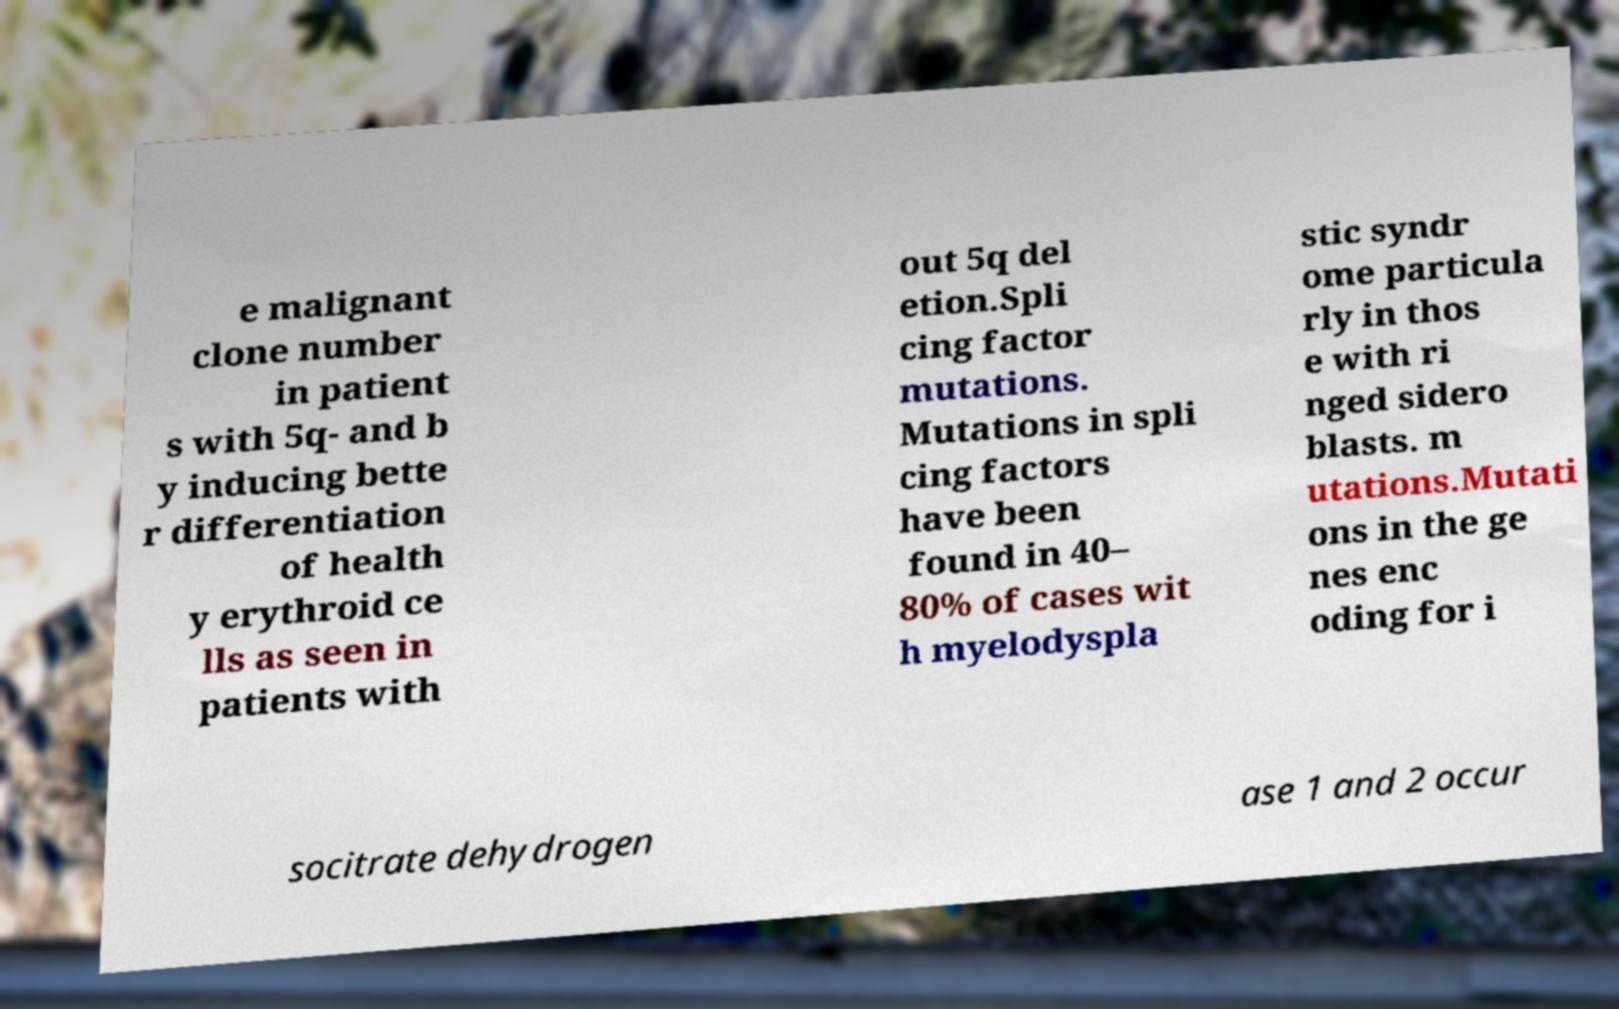Can you accurately transcribe the text from the provided image for me? e malignant clone number in patient s with 5q- and b y inducing bette r differentiation of health y erythroid ce lls as seen in patients with out 5q del etion.Spli cing factor mutations. Mutations in spli cing factors have been found in 40– 80% of cases wit h myelodyspla stic syndr ome particula rly in thos e with ri nged sidero blasts. m utations.Mutati ons in the ge nes enc oding for i socitrate dehydrogen ase 1 and 2 occur 